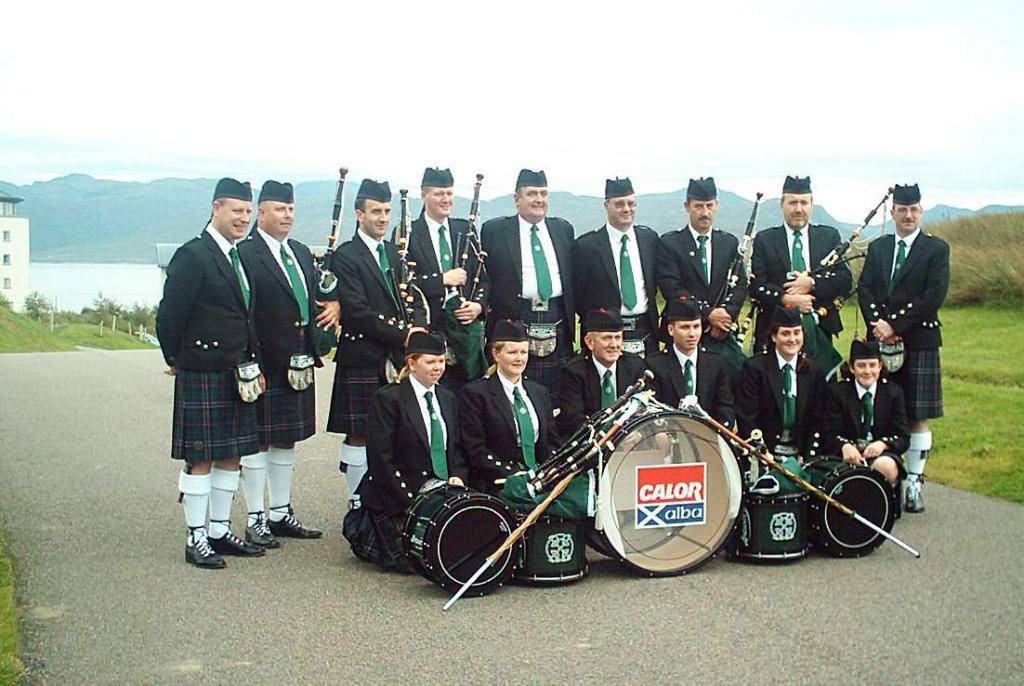Can you describe this image briefly? At the center of the image some people are sitting on the road and some are standing on the road. In front of them there are musical instruments. At the bottom of the image there is grass on the surface. In the background of the image there are buildings, trees, mountains and sky. At the center of the image there is water. 